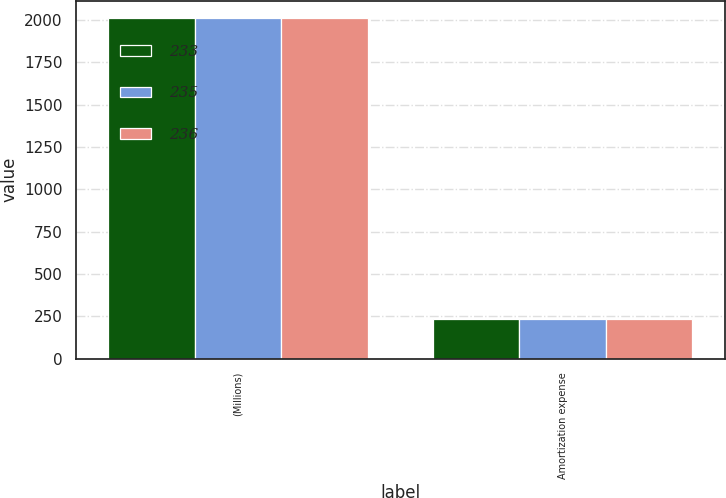Convert chart to OTSL. <chart><loc_0><loc_0><loc_500><loc_500><stacked_bar_chart><ecel><fcel>(Millions)<fcel>Amortization expense<nl><fcel>233<fcel>2013<fcel>236<nl><fcel>235<fcel>2012<fcel>233<nl><fcel>236<fcel>2011<fcel>235<nl></chart> 